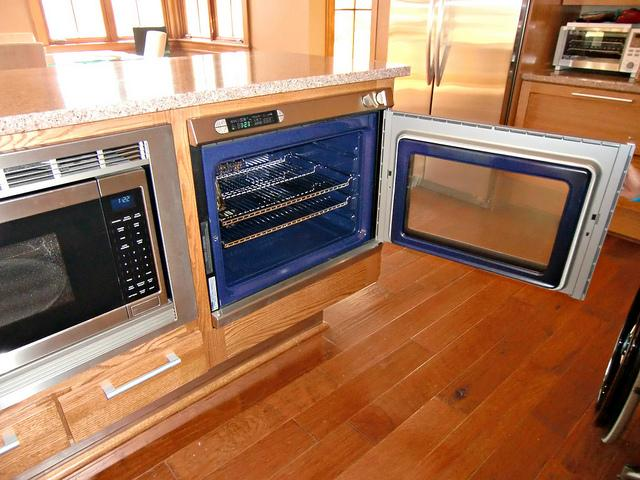What is the state of the blue item? open 